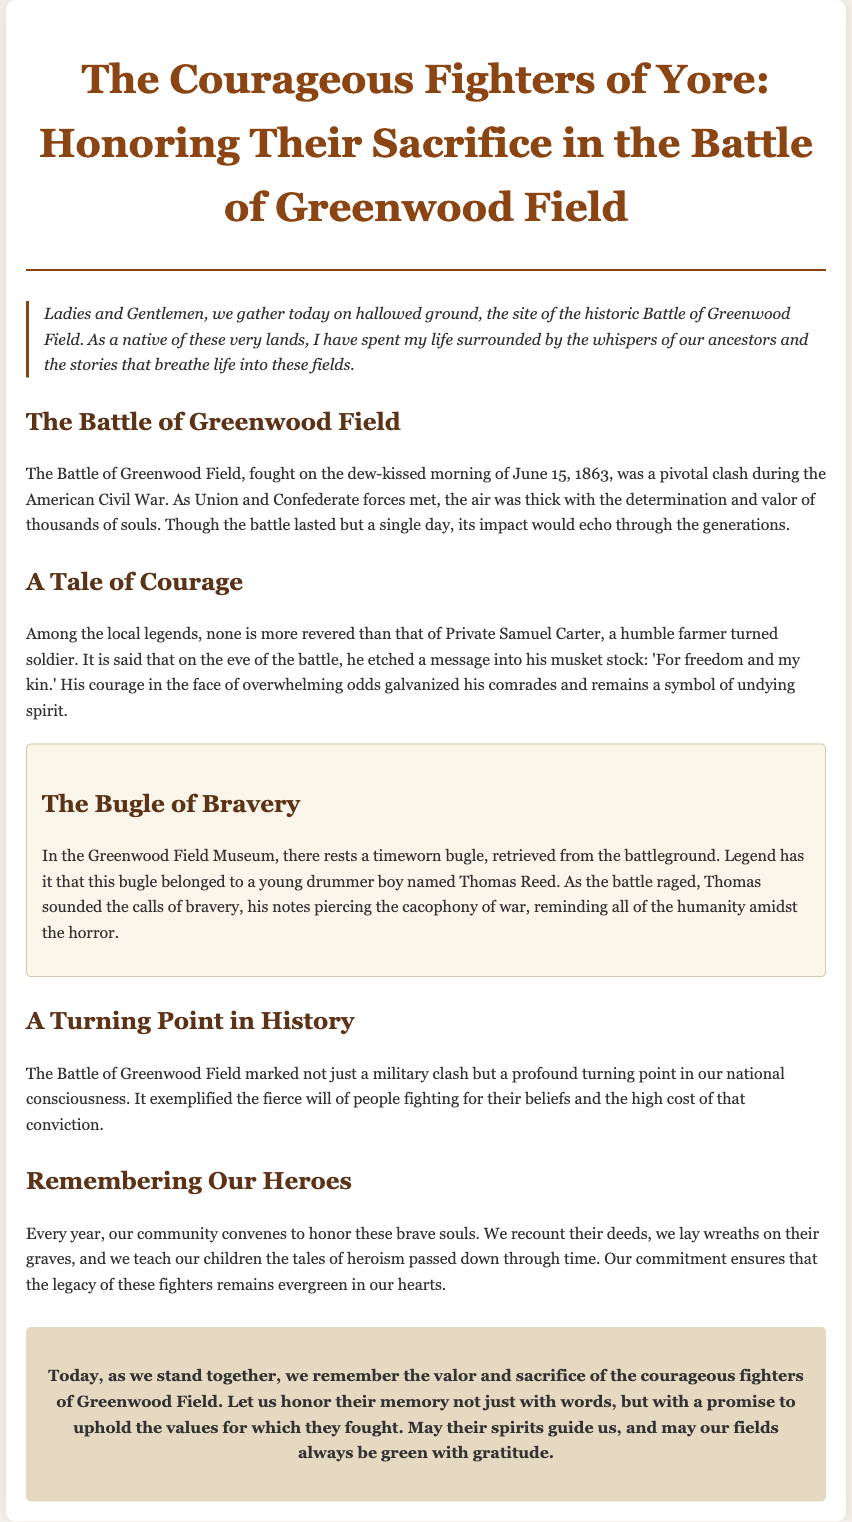What date was the Battle of Greenwood Field fought? The document explicitly states that the battle took place on June 15, 1863.
Answer: June 15, 1863 Who was the humble farmer turned soldier mentioned in the eulogy? The document mentions Private Samuel Carter as the farmer turned soldier.
Answer: Private Samuel Carter What message did Private Samuel Carter etch into his musket stock? It is noted in the document that he wrote "For freedom and my kin."
Answer: For freedom and my kin What artifact is housed in the Greenwood Field Museum? The eulogy specifically refers to a bugle as an artifact in the museum.
Answer: Bugle What was the name of the young drummer boy associated with the bugle? The document names Thomas Reed as the young drummer boy who owned the bugle.
Answer: Thomas Reed What significant impact did the Battle of Greenwood Field have according to the eulogy? The document indicates that the battle marked a profound turning point in national consciousness.
Answer: Turning point in national consciousness How does the community honor the heroes of the battle annually? The document states that the community convenes to recount their deeds and lay wreaths.
Answer: Lay wreaths What is a unique aspect of a eulogy highlighted in the document? The unique aspect mentioned is the commitment to uphold the values for which the fighters fought.
Answer: Commitment to uphold values 